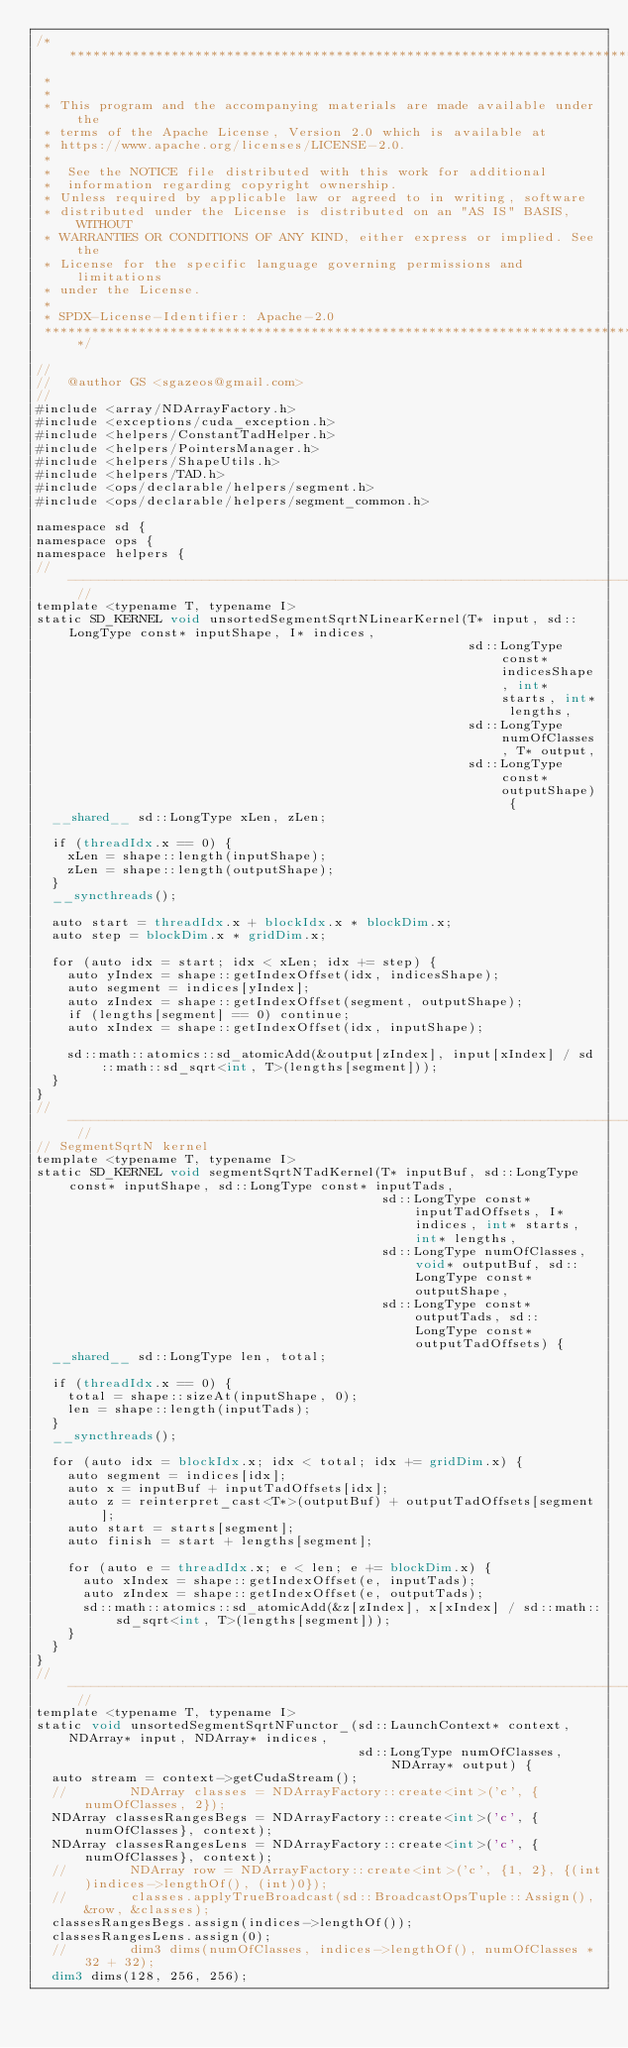<code> <loc_0><loc_0><loc_500><loc_500><_Cuda_>/* ******************************************************************************
 *
 *
 * This program and the accompanying materials are made available under the
 * terms of the Apache License, Version 2.0 which is available at
 * https://www.apache.org/licenses/LICENSE-2.0.
 *
 *  See the NOTICE file distributed with this work for additional
 *  information regarding copyright ownership.
 * Unless required by applicable law or agreed to in writing, software
 * distributed under the License is distributed on an "AS IS" BASIS, WITHOUT
 * WARRANTIES OR CONDITIONS OF ANY KIND, either express or implied. See the
 * License for the specific language governing permissions and limitations
 * under the License.
 *
 * SPDX-License-Identifier: Apache-2.0
 ******************************************************************************/

//
//  @author GS <sgazeos@gmail.com>
//
#include <array/NDArrayFactory.h>
#include <exceptions/cuda_exception.h>
#include <helpers/ConstantTadHelper.h>
#include <helpers/PointersManager.h>
#include <helpers/ShapeUtils.h>
#include <helpers/TAD.h>
#include <ops/declarable/helpers/segment.h>
#include <ops/declarable/helpers/segment_common.h>

namespace sd {
namespace ops {
namespace helpers {
// -------------------------------------------------------------------------------------------------------------- //
template <typename T, typename I>
static SD_KERNEL void unsortedSegmentSqrtNLinearKernel(T* input, sd::LongType const* inputShape, I* indices,
                                                       sd::LongType const* indicesShape, int* starts, int* lengths,
                                                       sd::LongType numOfClasses, T* output,
                                                       sd::LongType const* outputShape) {
  __shared__ sd::LongType xLen, zLen;

  if (threadIdx.x == 0) {
    xLen = shape::length(inputShape);
    zLen = shape::length(outputShape);
  }
  __syncthreads();

  auto start = threadIdx.x + blockIdx.x * blockDim.x;
  auto step = blockDim.x * gridDim.x;

  for (auto idx = start; idx < xLen; idx += step) {
    auto yIndex = shape::getIndexOffset(idx, indicesShape);
    auto segment = indices[yIndex];
    auto zIndex = shape::getIndexOffset(segment, outputShape);
    if (lengths[segment] == 0) continue;
    auto xIndex = shape::getIndexOffset(idx, inputShape);

    sd::math::atomics::sd_atomicAdd(&output[zIndex], input[xIndex] / sd::math::sd_sqrt<int, T>(lengths[segment]));
  }
}
// -------------------------------------------------------------------------------------------------------------- //
// SegmentSqrtN kernel
template <typename T, typename I>
static SD_KERNEL void segmentSqrtNTadKernel(T* inputBuf, sd::LongType const* inputShape, sd::LongType const* inputTads,
                                            sd::LongType const* inputTadOffsets, I* indices, int* starts, int* lengths,
                                            sd::LongType numOfClasses, void* outputBuf, sd::LongType const* outputShape,
                                            sd::LongType const* outputTads, sd::LongType const* outputTadOffsets) {
  __shared__ sd::LongType len, total;

  if (threadIdx.x == 0) {
    total = shape::sizeAt(inputShape, 0);
    len = shape::length(inputTads);
  }
  __syncthreads();

  for (auto idx = blockIdx.x; idx < total; idx += gridDim.x) {
    auto segment = indices[idx];
    auto x = inputBuf + inputTadOffsets[idx];
    auto z = reinterpret_cast<T*>(outputBuf) + outputTadOffsets[segment];
    auto start = starts[segment];
    auto finish = start + lengths[segment];

    for (auto e = threadIdx.x; e < len; e += blockDim.x) {
      auto xIndex = shape::getIndexOffset(e, inputTads);
      auto zIndex = shape::getIndexOffset(e, outputTads);
      sd::math::atomics::sd_atomicAdd(&z[zIndex], x[xIndex] / sd::math::sd_sqrt<int, T>(lengths[segment]));
    }
  }
}
// -------------------------------------------------------------------------------------------------------------- //
template <typename T, typename I>
static void unsortedSegmentSqrtNFunctor_(sd::LaunchContext* context, NDArray* input, NDArray* indices,
                                         sd::LongType numOfClasses, NDArray* output) {
  auto stream = context->getCudaStream();
  //        NDArray classes = NDArrayFactory::create<int>('c', {numOfClasses, 2});
  NDArray classesRangesBegs = NDArrayFactory::create<int>('c', {numOfClasses}, context);
  NDArray classesRangesLens = NDArrayFactory::create<int>('c', {numOfClasses}, context);
  //        NDArray row = NDArrayFactory::create<int>('c', {1, 2}, {(int)indices->lengthOf(), (int)0});
  //        classes.applyTrueBroadcast(sd::BroadcastOpsTuple::Assign(), &row, &classes);
  classesRangesBegs.assign(indices->lengthOf());
  classesRangesLens.assign(0);
  //        dim3 dims(numOfClasses, indices->lengthOf(), numOfClasses * 32 + 32);
  dim3 dims(128, 256, 256);</code> 